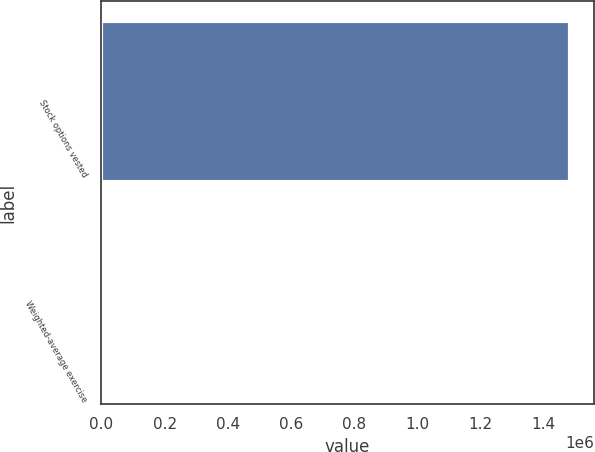Convert chart. <chart><loc_0><loc_0><loc_500><loc_500><bar_chart><fcel>Stock options vested<fcel>Weighted-average exercise<nl><fcel>1.48473e+06<fcel>47.05<nl></chart> 